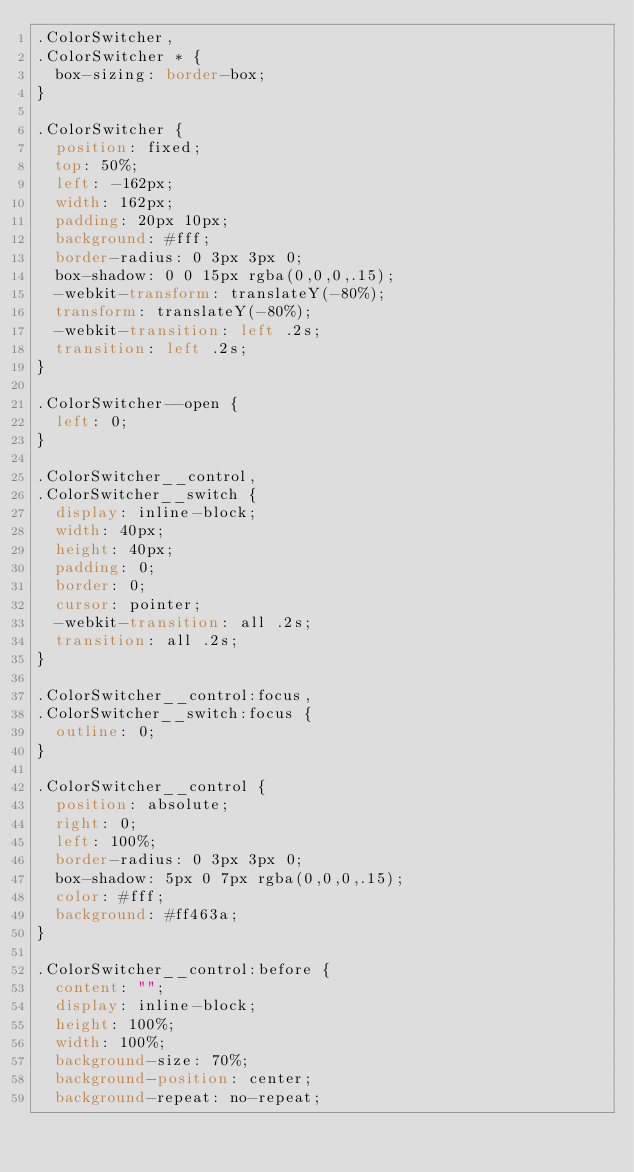<code> <loc_0><loc_0><loc_500><loc_500><_CSS_>.ColorSwitcher,
.ColorSwitcher * {
  box-sizing: border-box;
}

.ColorSwitcher {
  position: fixed;
  top: 50%;
  left: -162px;
  width: 162px;
  padding: 20px 10px;
  background: #fff;
  border-radius: 0 3px 3px 0;
  box-shadow: 0 0 15px rgba(0,0,0,.15);
  -webkit-transform: translateY(-80%);
  transform: translateY(-80%);
  -webkit-transition: left .2s;
  transition: left .2s;
}

.ColorSwitcher--open {
  left: 0;
}

.ColorSwitcher__control,
.ColorSwitcher__switch {
  display: inline-block;
  width: 40px;
  height: 40px;
  padding: 0;
  border: 0;
  cursor: pointer;
  -webkit-transition: all .2s;
  transition: all .2s;
}

.ColorSwitcher__control:focus,
.ColorSwitcher__switch:focus {
  outline: 0;
}

.ColorSwitcher__control {
  position: absolute;
  right: 0;
  left: 100%;
  border-radius: 0 3px 3px 0;
  box-shadow: 5px 0 7px rgba(0,0,0,.15);
  color: #fff;
  background: #ff463a;
}

.ColorSwitcher__control:before {
  content: "";
  display: inline-block;
  height: 100%;
  width: 100%;
  background-size: 70%;
  background-position: center;
  background-repeat: no-repeat;</code> 